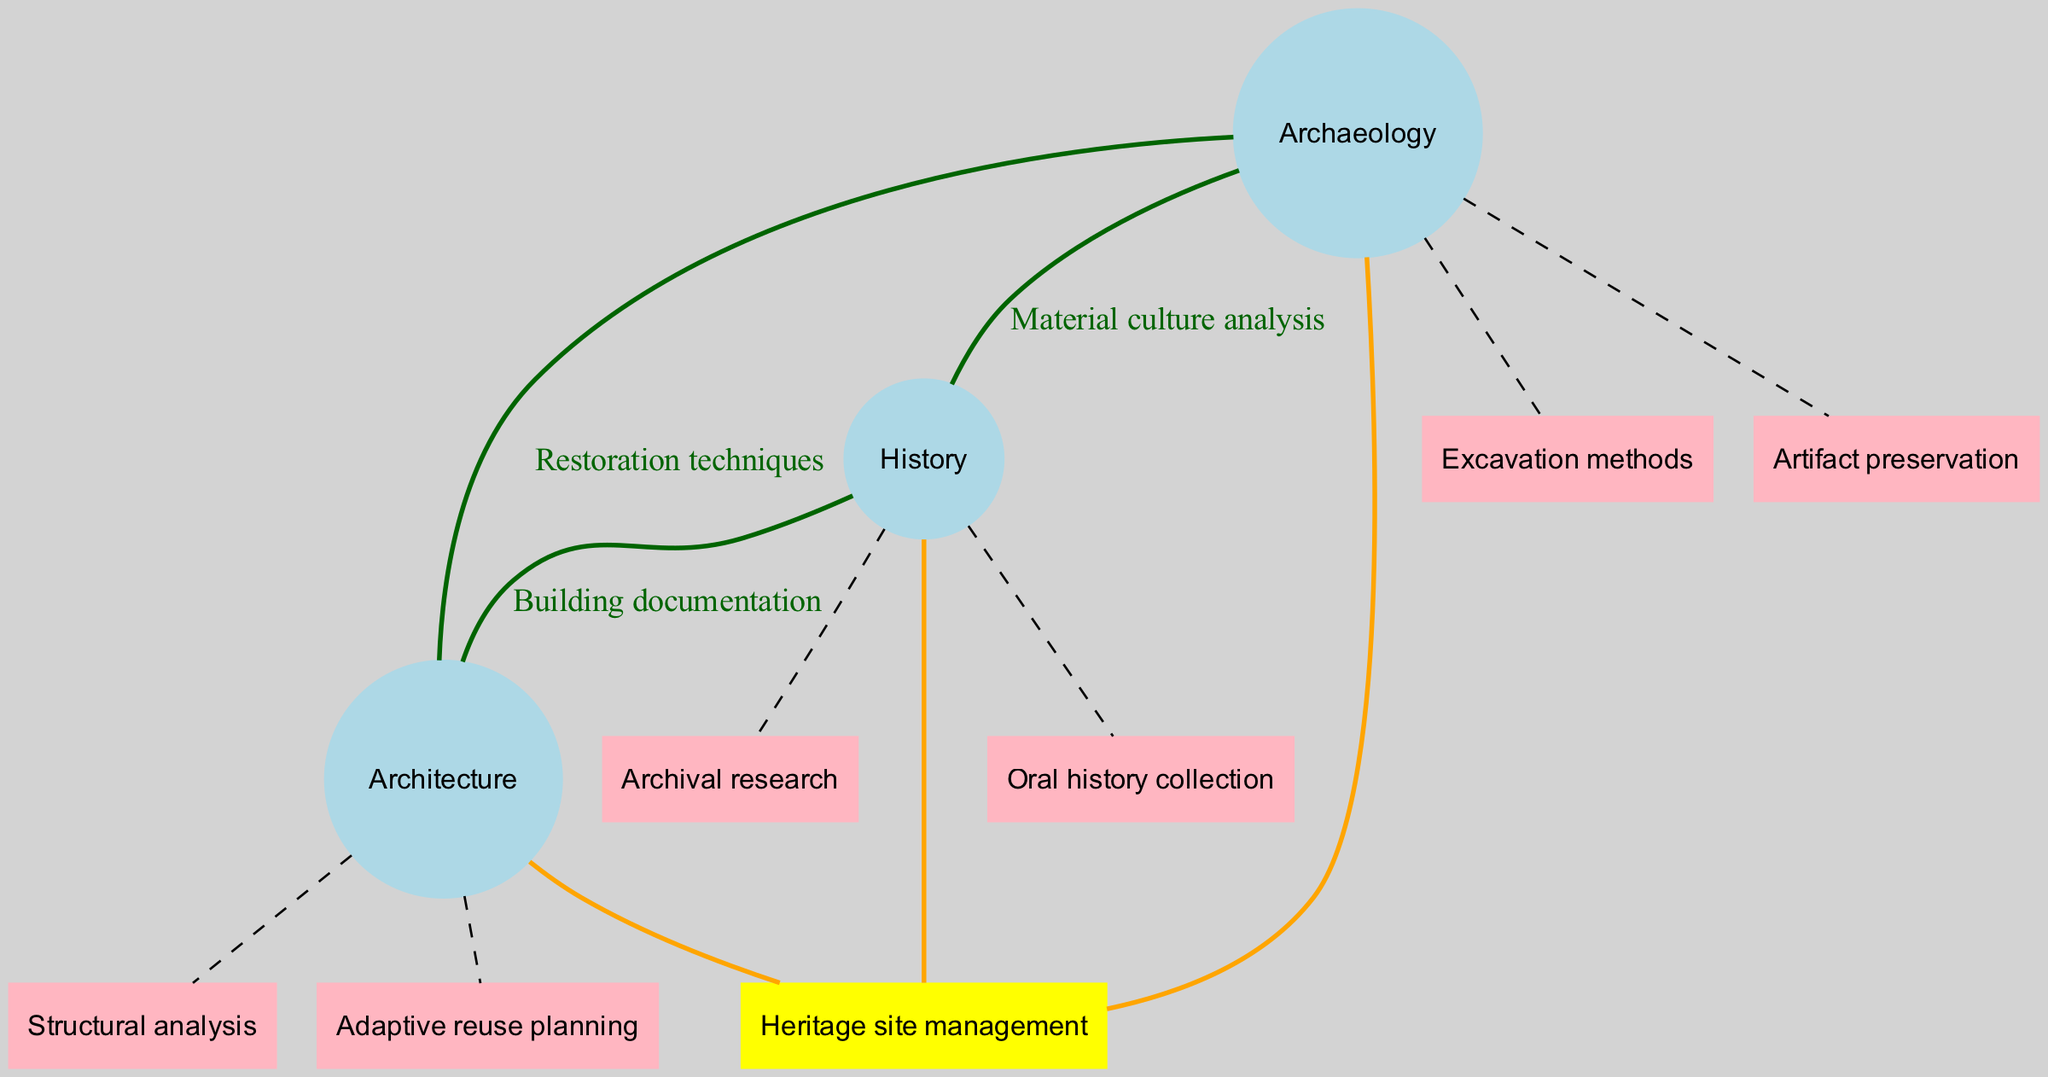What are the unique elements of Archaeology? In the diagram, unique elements for each discipline are listed around the set for Archaeology. The elements specified for Archaeology are "Excavation methods" and "Artifact preservation".
Answer: Excavation methods, Artifact preservation How many main academic disciplines are represented in the diagram? The diagram includes three main disciplines: Archaeology, History, and Architecture. By counting the number of sets defined in the data, we find there are three.
Answer: 3 What is the label of the intersection between History and Architecture? The intersection between History and Architecture has the label "Building documentation". This is visually represented where the edges connect these two nodes in the diagram.
Answer: Building documentation Which unique element is related to Architecture? The unique elements of Architecture are listed around that set and include "Structural analysis" and "Adaptive reuse planning". Therefore, either of these can be an answer.
Answer: Structural analysis, Adaptive reuse planning How many intersections are there in total? The total number of intersections defined in the data includes combinations of the main academic disciplines. There are four intersections detailed, including those involving two and three sets.
Answer: 4 What intersection involves all three disciplines? The element that includes all three disciplines – Archaeology, History, and Architecture – is "Heritage site management". This intersection is clearly indicated in the diagram as a central label connecting all three sets.
Answer: Heritage site management Which discipline has "Oral history collection" as a unique element? By examining the unique elements, "Oral history collection" is listed under the History set. This element is specifically attributed to the History discipline in the diagram.
Answer: History What kind of analysis connects Archaeology and History? The analysis that connects Archaeology and History is labeled "Material culture analysis". This is represented in the intersection area of the two disciplines on the diagram.
Answer: Material culture analysis What color represents unique elements in the diagram? Unique elements in the diagram are represented in light pink boxes, distinguishing them visually from other types of nodes and interactions shown in the diagram.
Answer: Light pink 